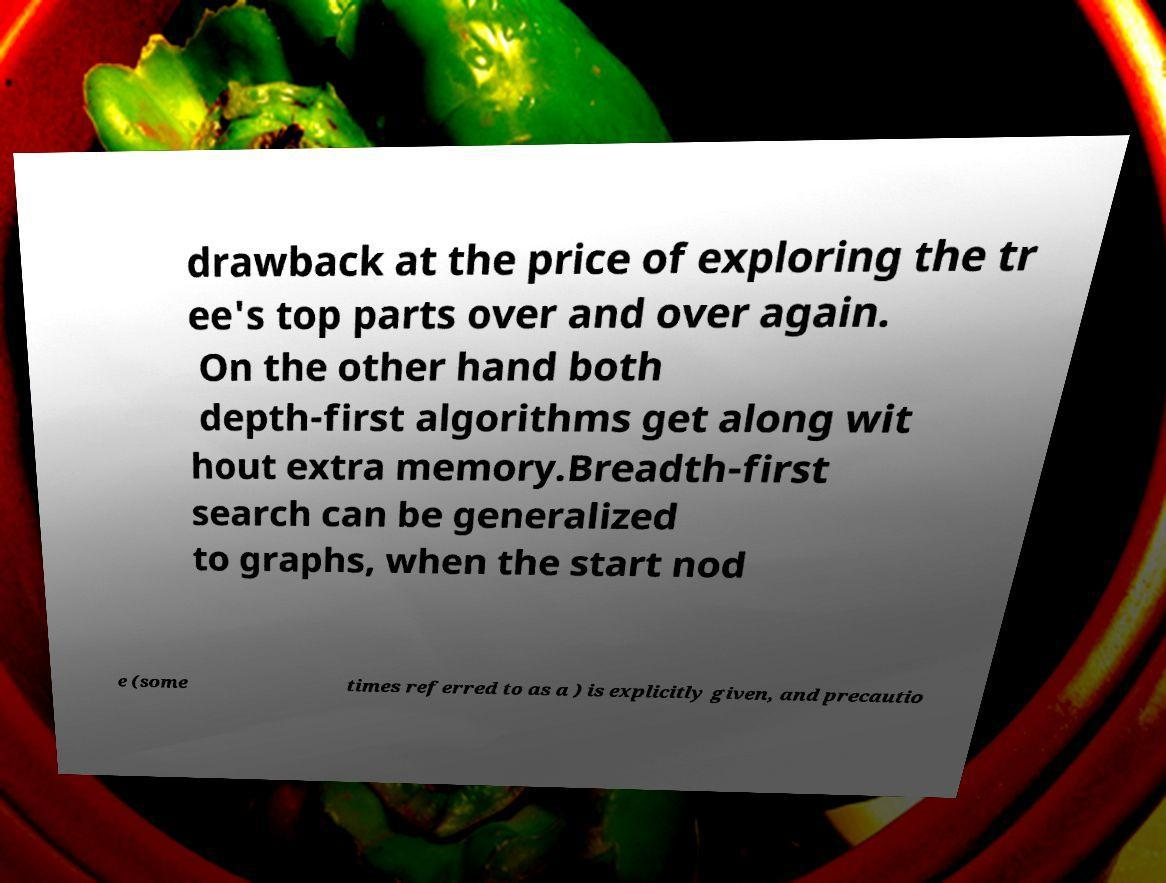Please identify and transcribe the text found in this image. drawback at the price of exploring the tr ee's top parts over and over again. On the other hand both depth-first algorithms get along wit hout extra memory.Breadth-first search can be generalized to graphs, when the start nod e (some times referred to as a ) is explicitly given, and precautio 